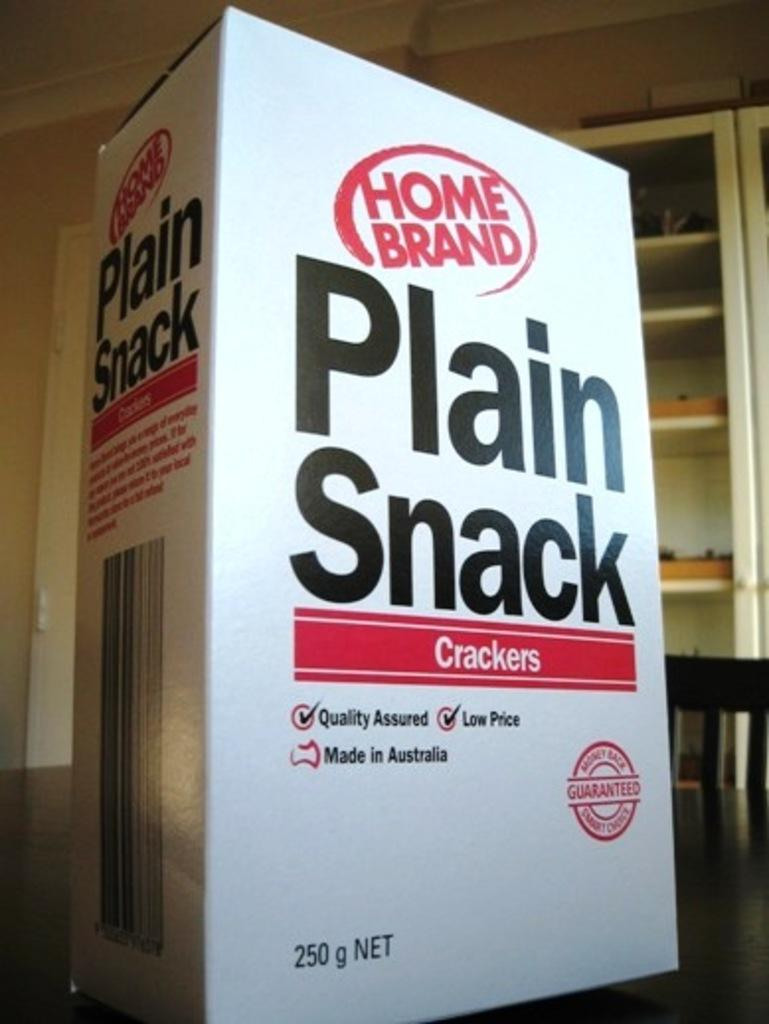<image>
Provide a brief description of the given image. a white box of home brand plain snack crakers 